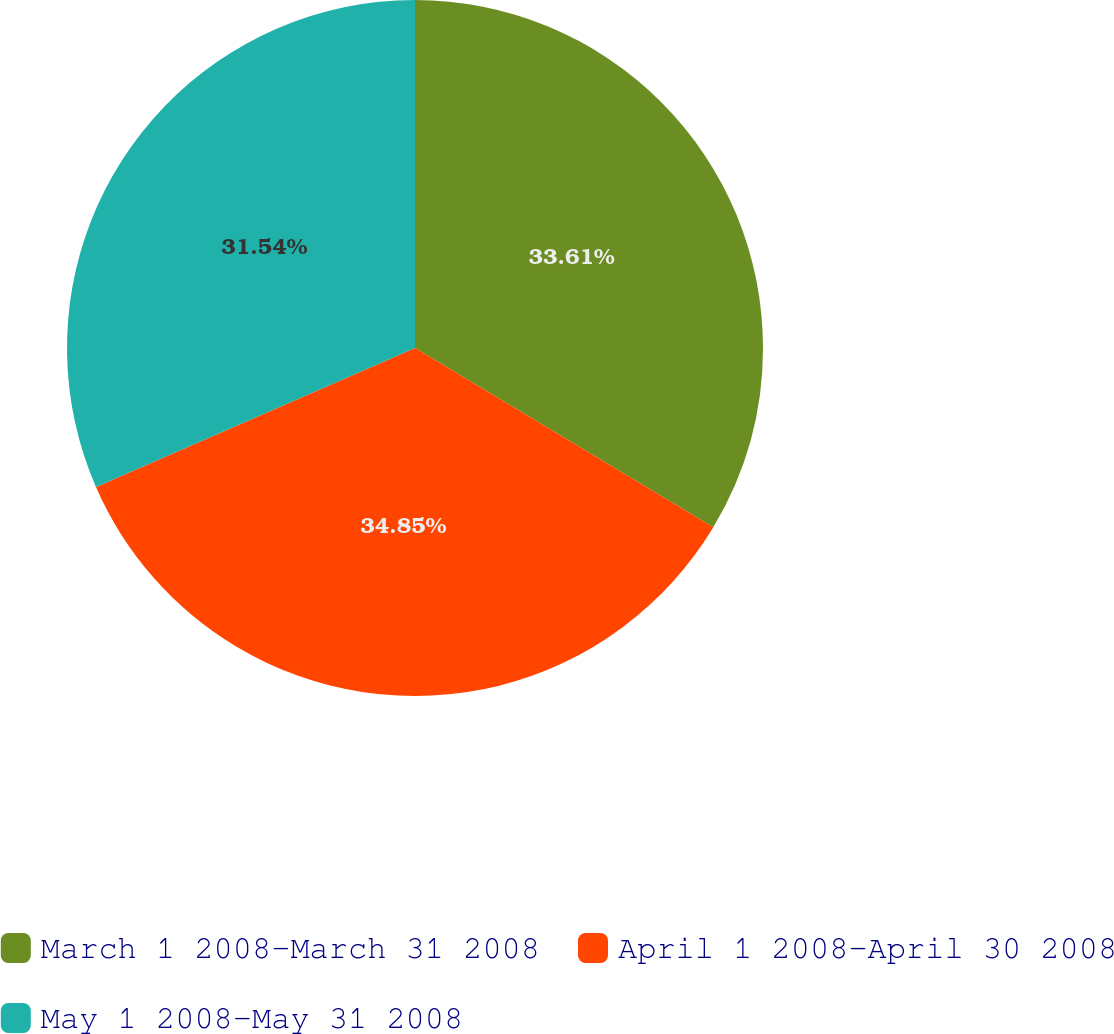Convert chart to OTSL. <chart><loc_0><loc_0><loc_500><loc_500><pie_chart><fcel>March 1 2008-March 31 2008<fcel>April 1 2008-April 30 2008<fcel>May 1 2008-May 31 2008<nl><fcel>33.61%<fcel>34.85%<fcel>31.54%<nl></chart> 